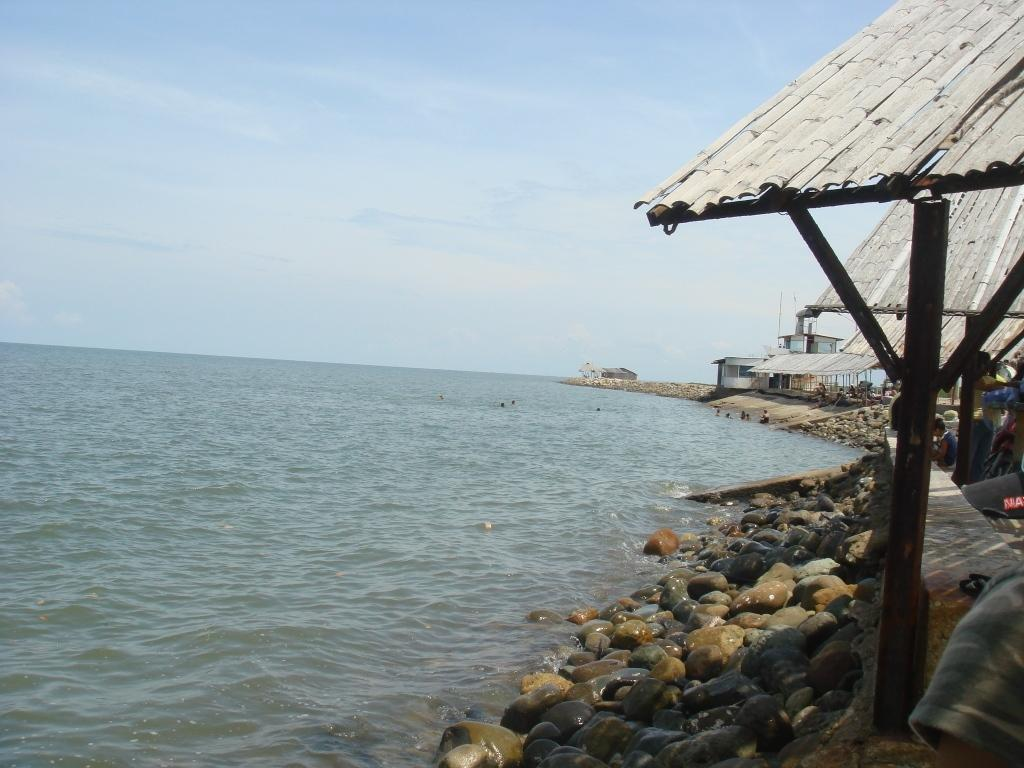What type of landscape is at the bottom of the image? There is a beach at the bottom of the image. What structures can be seen on the right side of the image? There are houses on the right side of the image. What type of terrain is present in the image? Small stones are present in the image. Who or what is visible in the image? There are persons in the image. What is visible at the top of the image? The sky is visible at the top of the image. What type of knowledge is being shared on the desk in the image? There is no desk present in the image, so no knowledge can be shared on a desk. 